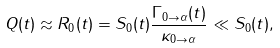<formula> <loc_0><loc_0><loc_500><loc_500>Q ( t ) \approx R _ { 0 } ( t ) = S _ { 0 } ( t ) \frac { \Gamma _ { 0 \rightarrow \alpha } ( t ) } { \kappa _ { 0 \rightarrow \alpha } } \ll S _ { 0 } ( t ) ,</formula> 